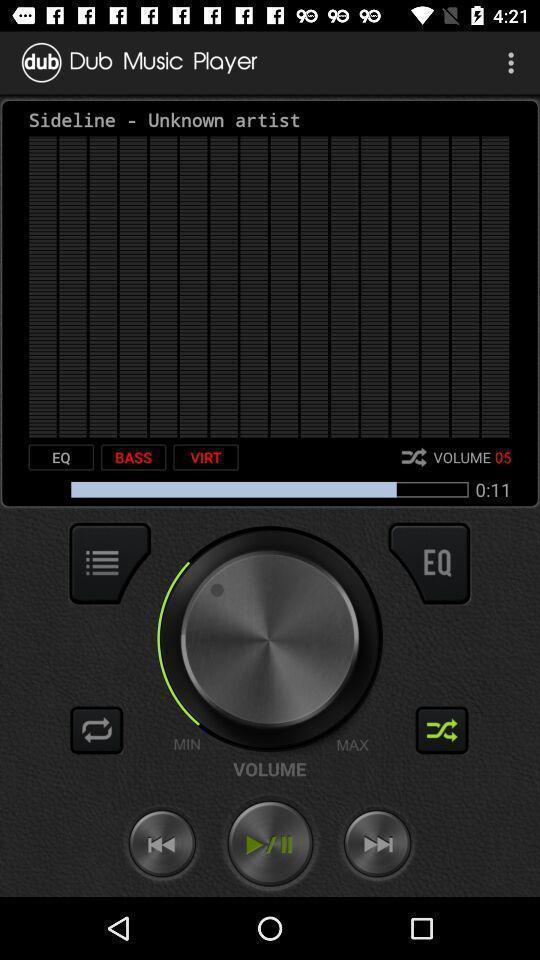Summarize the information in this screenshot. Screen showing of a music application. 